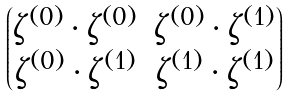Convert formula to latex. <formula><loc_0><loc_0><loc_500><loc_500>\begin{pmatrix} { \zeta } ^ { ( 0 ) } \cdot { \zeta } ^ { ( 0 ) } & { \zeta } ^ { ( 0 ) } \cdot { \zeta } ^ { ( 1 ) } \\ { \zeta } ^ { ( 0 ) } \cdot { \zeta } ^ { ( 1 ) } & { \zeta } ^ { ( 1 ) } \cdot { \zeta } ^ { ( 1 ) } \end{pmatrix}</formula> 